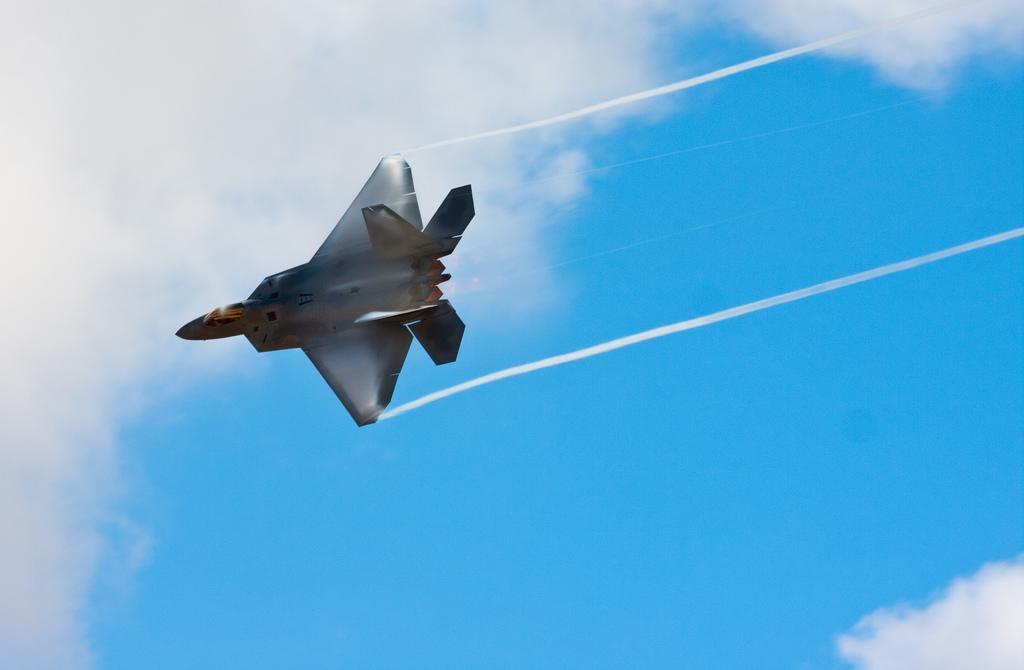Please provide a concise description of this image. In this image we can see a Jet plane and the sky is in the background. 